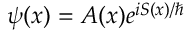<formula> <loc_0><loc_0><loc_500><loc_500>\psi ( x ) = A ( x ) e ^ { i S ( x ) / }</formula> 